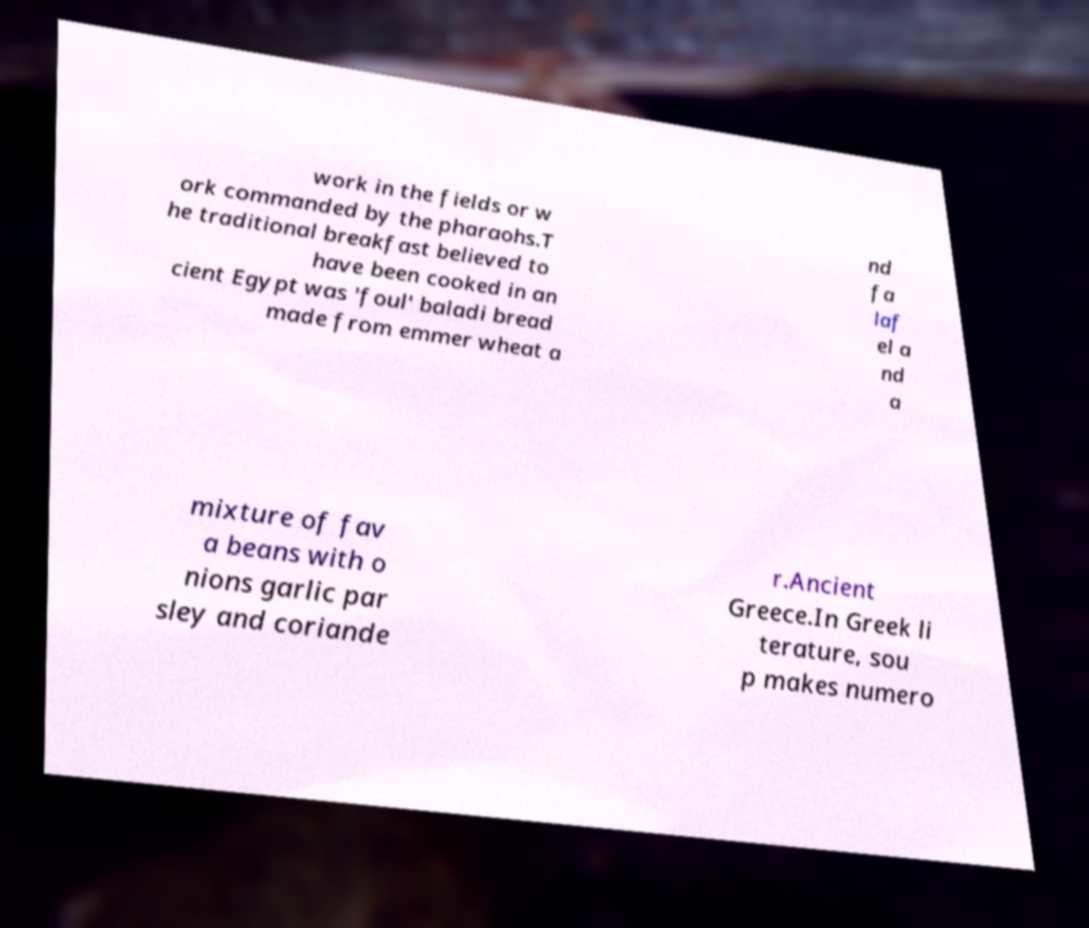I need the written content from this picture converted into text. Can you do that? work in the fields or w ork commanded by the pharaohs.T he traditional breakfast believed to have been cooked in an cient Egypt was 'foul' baladi bread made from emmer wheat a nd fa laf el a nd a mixture of fav a beans with o nions garlic par sley and coriande r.Ancient Greece.In Greek li terature, sou p makes numero 